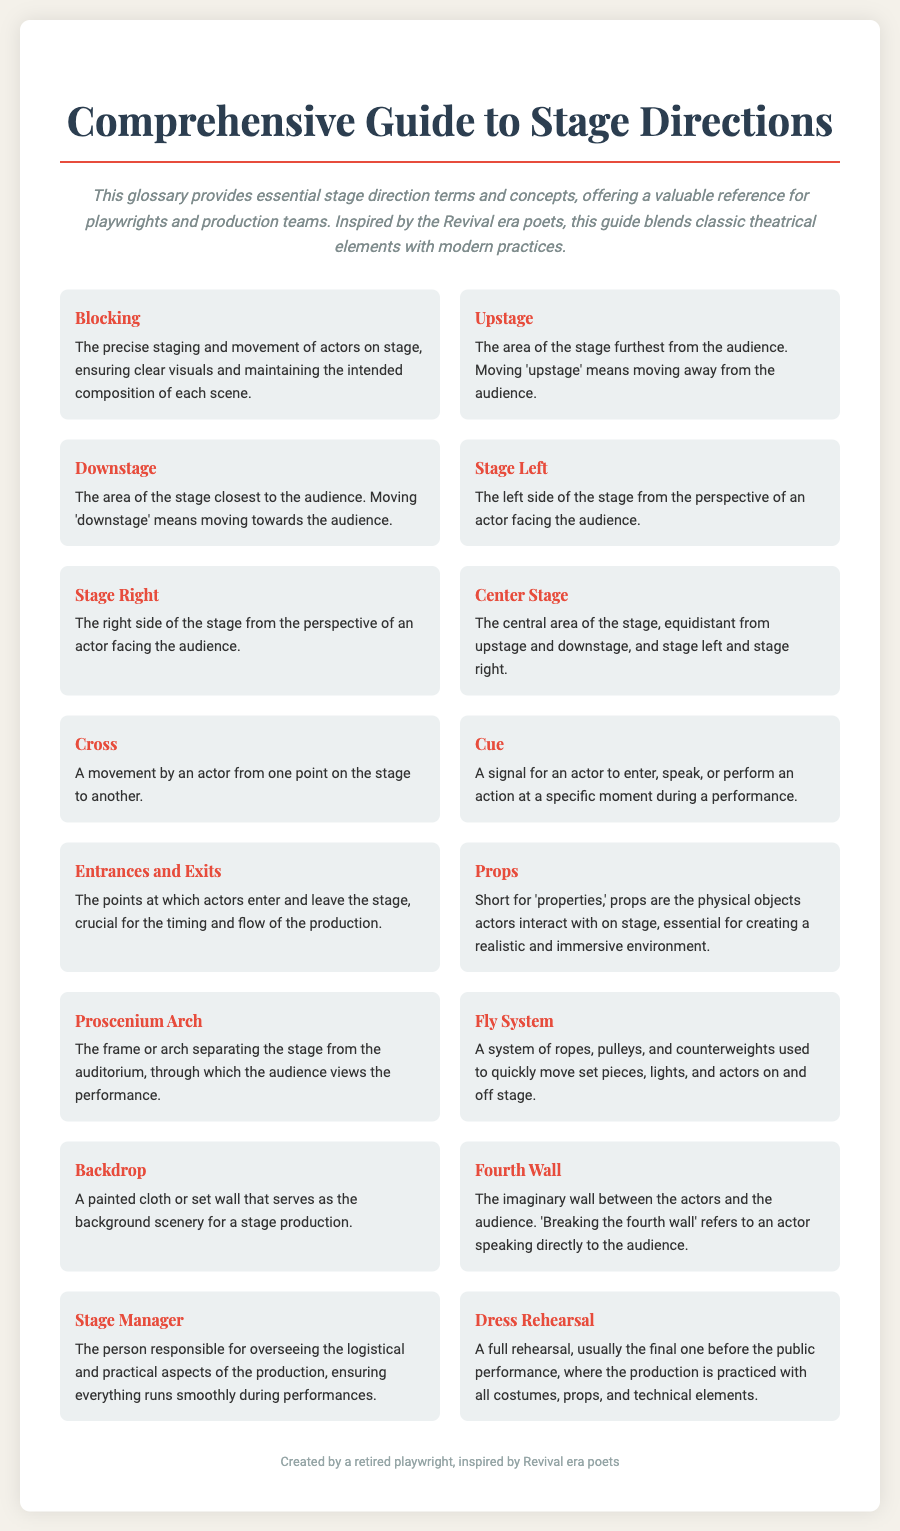What does "Blocking" refer to? "Blocking" is defined in the glossary as the precise staging and movement of actors on stage.
Answer: Precise staging and movement of actors What is the definition of "Stage Left"? The definition of "Stage Left" states it is the left side of the stage from the perspective of an actor facing the audience.
Answer: Left side of the stage What is a "Cue"? A "Cue" is identified as a signal for an actor to enter, speak, or perform an action at a specific moment.
Answer: Signal for an actor What role does a "Stage Manager" play? The glossary defines the "Stage Manager" as the person responsible for overseeing the logistical and practical aspects of the production.
Answer: Oversight of production logistics How many glossary terms are listed in the document? The document contains a total of 15 glossary terms as indicated by the number of entries in the glossary section.
Answer: 15 What does "Breaking the fourth wall" mean? "Breaking the fourth wall" is described as an actor speaking directly to the audience.
Answer: Speaking directly to the audience What is the purpose of "Dress Rehearsal"? The purpose of a "Dress Rehearsal" is for a full rehearsal with all costumes, props, and technical elements practiced.
Answer: Full rehearsal before performance Where does the audience view the performance? The audience views the performance through the "Proscenium Arch" which separates the stage from the auditorium.
Answer: Proscenium Arch 